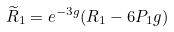Convert formula to latex. <formula><loc_0><loc_0><loc_500><loc_500>\widetilde { R } _ { 1 } = e ^ { - 3 g } ( R _ { 1 } - 6 P _ { 1 } g )</formula> 